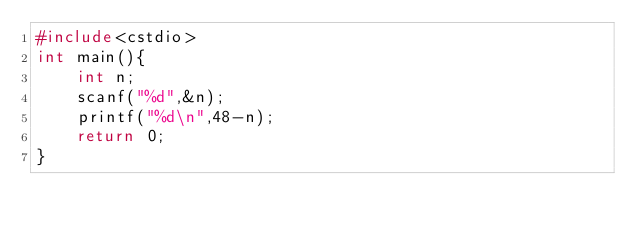<code> <loc_0><loc_0><loc_500><loc_500><_C++_>#include<cstdio>
int main(){
	int n;
	scanf("%d",&n);
	printf("%d\n",48-n);
	return 0;
}</code> 